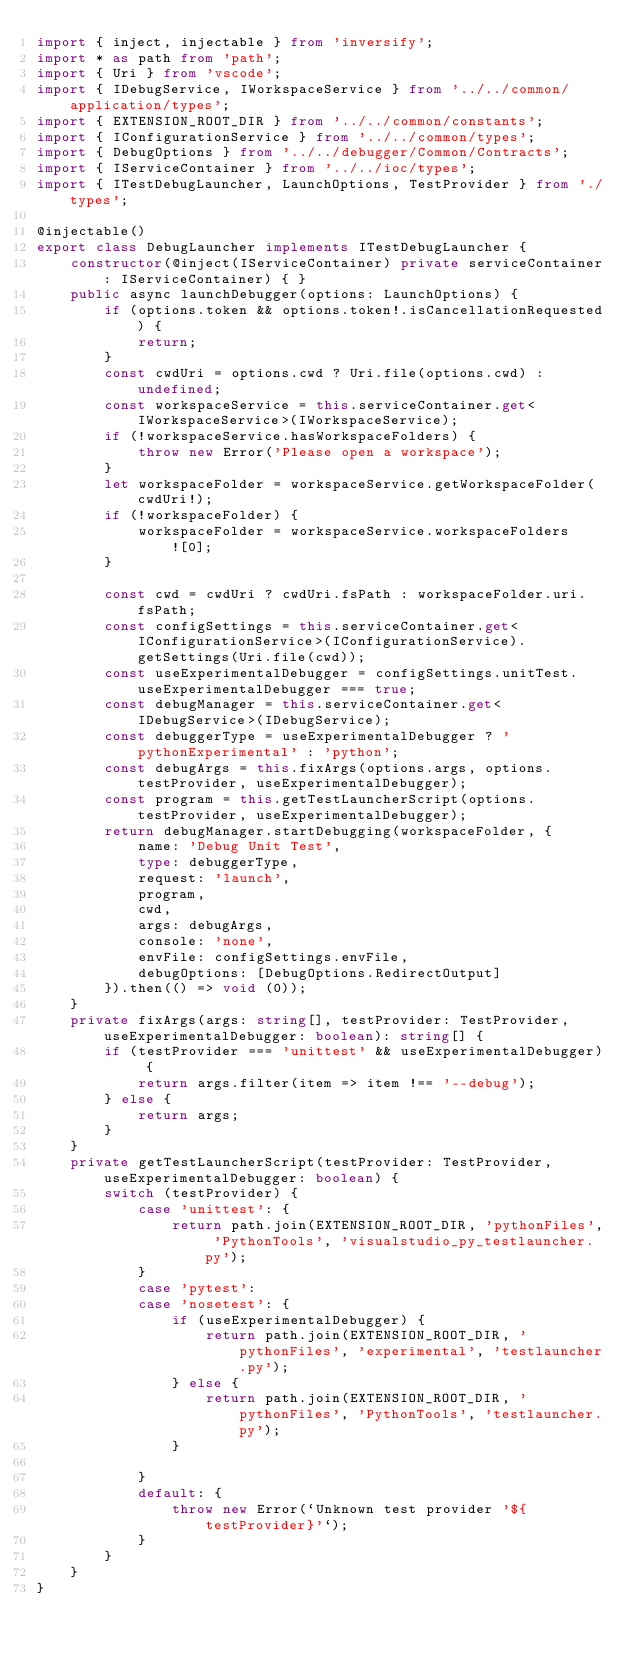Convert code to text. <code><loc_0><loc_0><loc_500><loc_500><_TypeScript_>import { inject, injectable } from 'inversify';
import * as path from 'path';
import { Uri } from 'vscode';
import { IDebugService, IWorkspaceService } from '../../common/application/types';
import { EXTENSION_ROOT_DIR } from '../../common/constants';
import { IConfigurationService } from '../../common/types';
import { DebugOptions } from '../../debugger/Common/Contracts';
import { IServiceContainer } from '../../ioc/types';
import { ITestDebugLauncher, LaunchOptions, TestProvider } from './types';

@injectable()
export class DebugLauncher implements ITestDebugLauncher {
    constructor(@inject(IServiceContainer) private serviceContainer: IServiceContainer) { }
    public async launchDebugger(options: LaunchOptions) {
        if (options.token && options.token!.isCancellationRequested) {
            return;
        }
        const cwdUri = options.cwd ? Uri.file(options.cwd) : undefined;
        const workspaceService = this.serviceContainer.get<IWorkspaceService>(IWorkspaceService);
        if (!workspaceService.hasWorkspaceFolders) {
            throw new Error('Please open a workspace');
        }
        let workspaceFolder = workspaceService.getWorkspaceFolder(cwdUri!);
        if (!workspaceFolder) {
            workspaceFolder = workspaceService.workspaceFolders![0];
        }

        const cwd = cwdUri ? cwdUri.fsPath : workspaceFolder.uri.fsPath;
        const configSettings = this.serviceContainer.get<IConfigurationService>(IConfigurationService).getSettings(Uri.file(cwd));
        const useExperimentalDebugger = configSettings.unitTest.useExperimentalDebugger === true;
        const debugManager = this.serviceContainer.get<IDebugService>(IDebugService);
        const debuggerType = useExperimentalDebugger ? 'pythonExperimental' : 'python';
        const debugArgs = this.fixArgs(options.args, options.testProvider, useExperimentalDebugger);
        const program = this.getTestLauncherScript(options.testProvider, useExperimentalDebugger);
        return debugManager.startDebugging(workspaceFolder, {
            name: 'Debug Unit Test',
            type: debuggerType,
            request: 'launch',
            program,
            cwd,
            args: debugArgs,
            console: 'none',
            envFile: configSettings.envFile,
            debugOptions: [DebugOptions.RedirectOutput]
        }).then(() => void (0));
    }
    private fixArgs(args: string[], testProvider: TestProvider, useExperimentalDebugger: boolean): string[] {
        if (testProvider === 'unittest' && useExperimentalDebugger) {
            return args.filter(item => item !== '--debug');
        } else {
            return args;
        }
    }
    private getTestLauncherScript(testProvider: TestProvider, useExperimentalDebugger: boolean) {
        switch (testProvider) {
            case 'unittest': {
                return path.join(EXTENSION_ROOT_DIR, 'pythonFiles', 'PythonTools', 'visualstudio_py_testlauncher.py');
            }
            case 'pytest':
            case 'nosetest': {
                if (useExperimentalDebugger) {
                    return path.join(EXTENSION_ROOT_DIR, 'pythonFiles', 'experimental', 'testlauncher.py');
                } else {
                    return path.join(EXTENSION_ROOT_DIR, 'pythonFiles', 'PythonTools', 'testlauncher.py');
                }

            }
            default: {
                throw new Error(`Unknown test provider '${testProvider}'`);
            }
        }
    }
}
</code> 